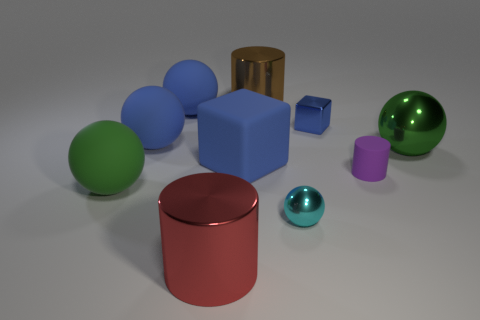Subtract all tiny purple matte cylinders. How many cylinders are left? 2 Subtract all purple cylinders. How many cylinders are left? 2 Subtract all cylinders. How many objects are left? 7 Subtract 3 spheres. How many spheres are left? 2 Subtract 0 yellow balls. How many objects are left? 10 Subtract all cyan cubes. Subtract all blue spheres. How many cubes are left? 2 Subtract all yellow balls. How many yellow blocks are left? 0 Subtract all large cyan matte things. Subtract all big blue rubber cubes. How many objects are left? 9 Add 8 small purple matte things. How many small purple matte things are left? 9 Add 6 small cyan shiny things. How many small cyan shiny things exist? 7 